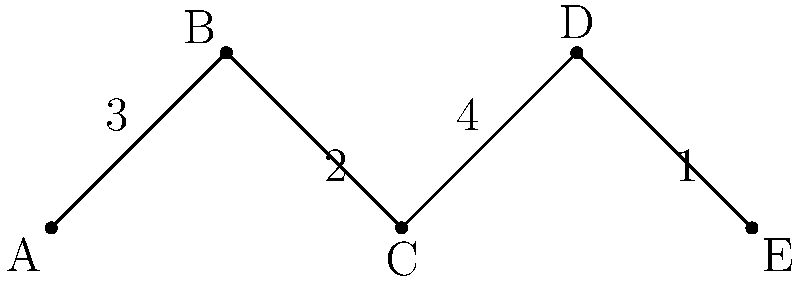In your garden, you have five plots (A, B, C, D, E) connected by paths. The graph represents the layout, where vertices are plots and edges are paths. Edge weights indicate the time (in minutes) to walk between adjacent plots. What's the minimum time needed to visit all plots, starting and ending at plot A, without revisiting any plot? To solve this problem, we need to find the Hamiltonian path with the lowest total weight, starting and ending at A. Let's break it down step-by-step:

1. Identify all possible Hamiltonian paths starting and ending at A:
   - A-B-C-D-E-A
   - A-E-D-C-B-A

2. Calculate the total time for each path:
   - A-B-C-D-E-A: 3 + 2 + 4 + 1 + (3 + 2 + 4) = 19 minutes
   - A-E-D-C-B-A: (3 + 2 + 4) + 1 + 4 + 2 + 3 = 19 minutes

3. Both paths take the same amount of time, so either is a valid solution.

4. The minimum time needed is 19 minutes.

This approach ensures visiting all plots once, starting and ending at A, while minimizing the total time spent walking between plots.
Answer: 19 minutes 